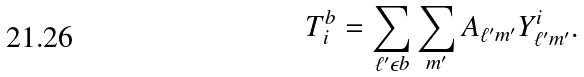<formula> <loc_0><loc_0><loc_500><loc_500>T ^ { b } _ { i } = \sum _ { \ell ^ { \prime } \epsilon b } \sum _ { m ^ { \prime } } A _ { \ell ^ { \prime } m ^ { \prime } } Y _ { \ell ^ { \prime } m ^ { \prime } } ^ { i } .</formula> 